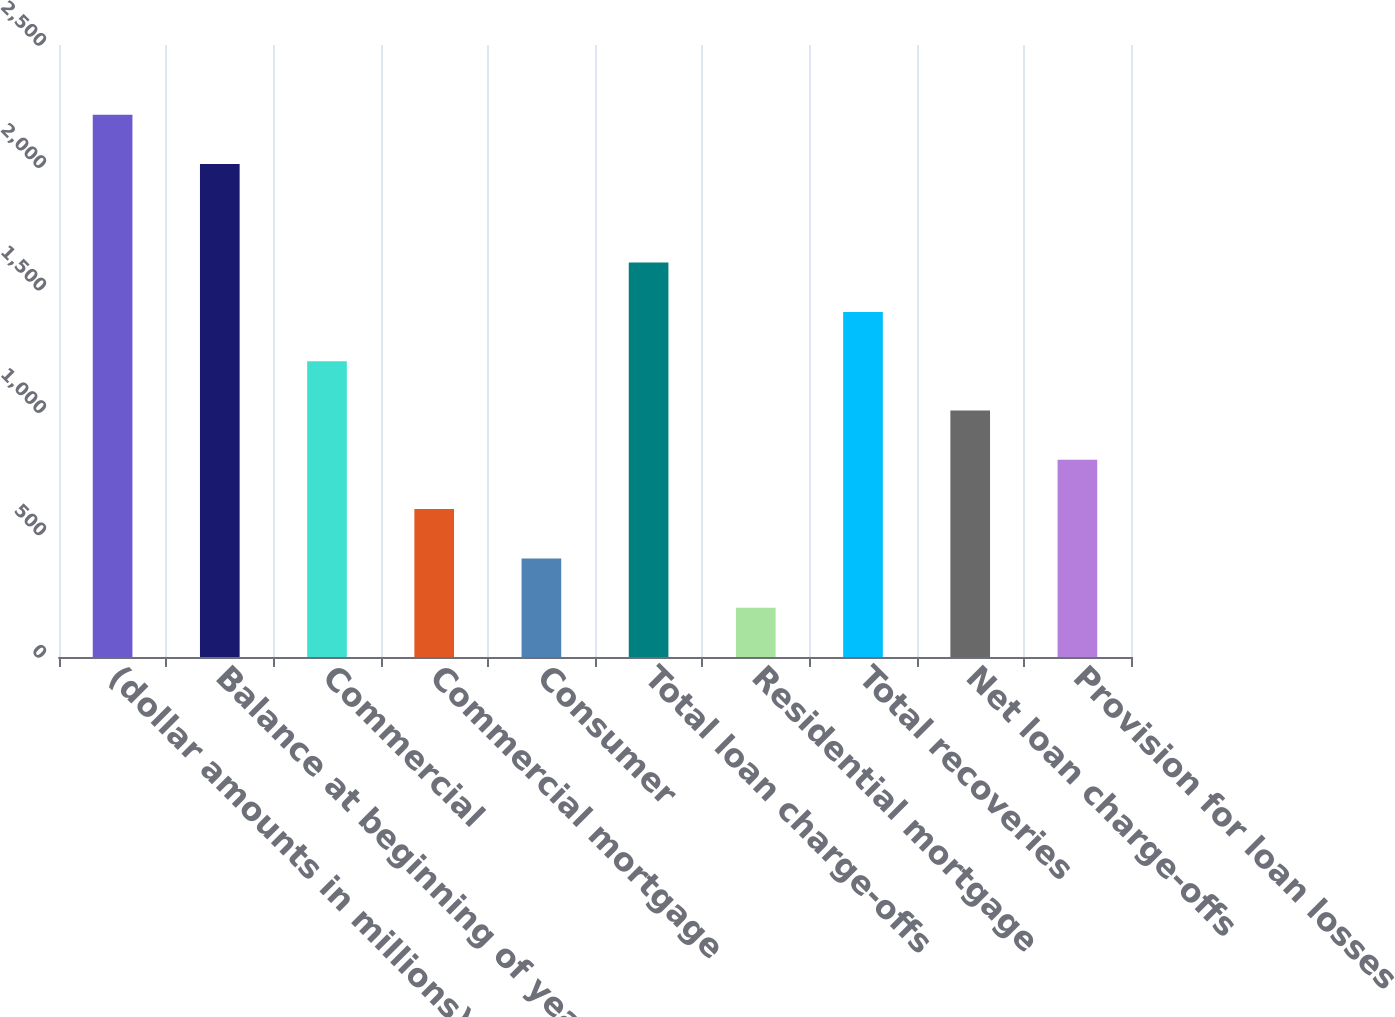Convert chart to OTSL. <chart><loc_0><loc_0><loc_500><loc_500><bar_chart><fcel>(dollar amounts in millions)<fcel>Balance at beginning of year<fcel>Commercial<fcel>Commercial mortgage<fcel>Consumer<fcel>Total loan charge-offs<fcel>Residential mortgage<fcel>Total recoveries<fcel>Net loan charge-offs<fcel>Provision for loan losses<nl><fcel>2215.39<fcel>2014<fcel>1208.42<fcel>604.25<fcel>402.85<fcel>1611.21<fcel>201.45<fcel>1409.82<fcel>1007.03<fcel>805.64<nl></chart> 